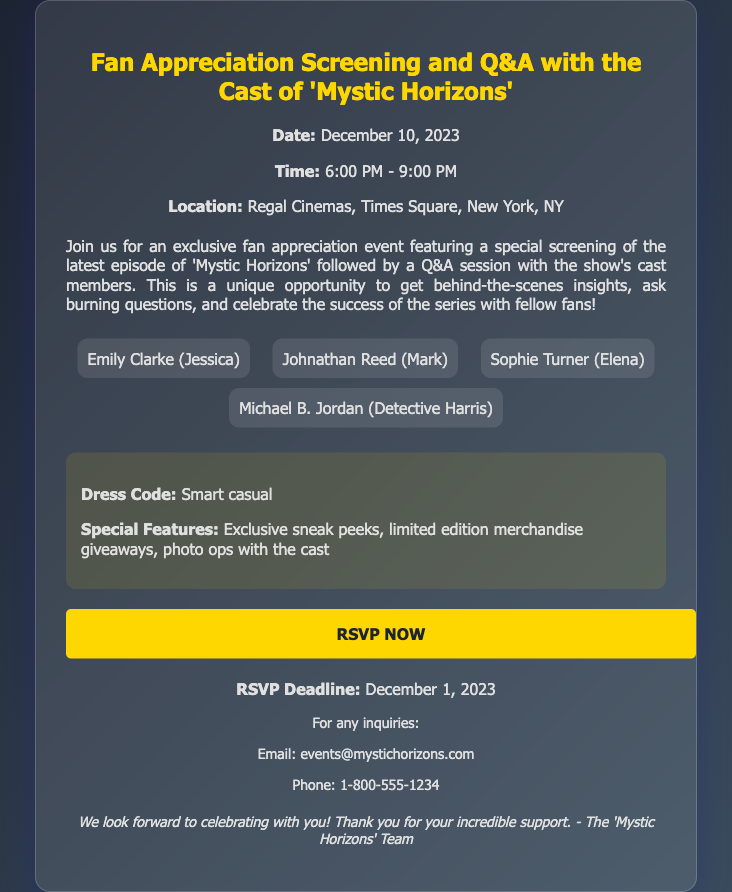What is the event date? The event date is explicitly mentioned in the document.
Answer: December 10, 2023 What time does the event start? The start time can be found in the event details section.
Answer: 6:00 PM Where is the event located? The location is provided in the event details.
Answer: Regal Cinemas, Times Square, New York, NY Who plays Jessica in the show? This information is available in the cast list section of the document.
Answer: Emily Clarke What is the RSVP deadline? The RSVP deadline is explicitly stated in the document.
Answer: December 1, 2023 What is the dress code for the event? The dress code is mentioned in the additional info section.
Answer: Smart casual What can attendees expect during the event? Reasoning over the information provided in the description and additional info section.
Answer: Exclusive sneak peeks, limited edition merchandise giveaways, photo ops with the cast What is the purpose of the event? The purpose is described in the document, requiring reasoning over the description.
Answer: Fan appreciation and Q&A with the cast 